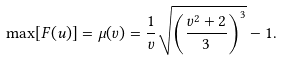<formula> <loc_0><loc_0><loc_500><loc_500>\max [ F ( u ) ] = \mu ( v ) = \frac { 1 } { v } \sqrt { \left ( \frac { v ^ { 2 } + 2 } { 3 } \right ) ^ { 3 } } - 1 .</formula> 